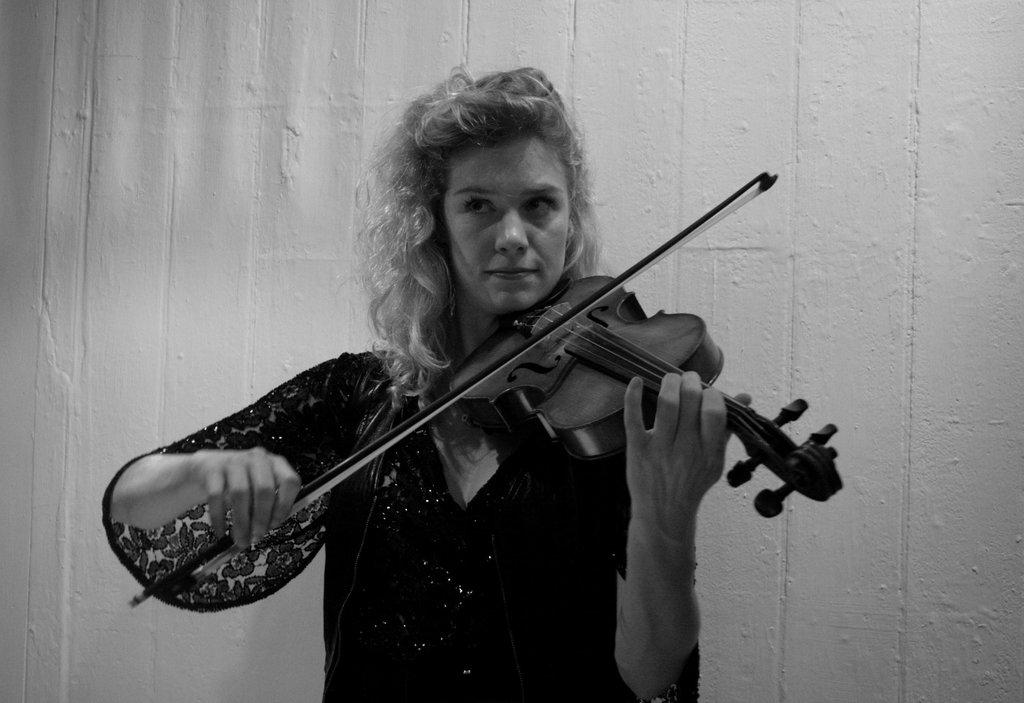Who is the main subject in the image? There is a woman in the image. What is the woman wearing? The woman is wearing a black dress. What is the woman holding in her hand? The woman is holding a musical instrument in her hand. How many pizzas can be seen in the image? There are no pizzas present in the image. What type of garden is visible in the background of the image? There is no garden visible in the image; it features a woman holding a musical instrument. 